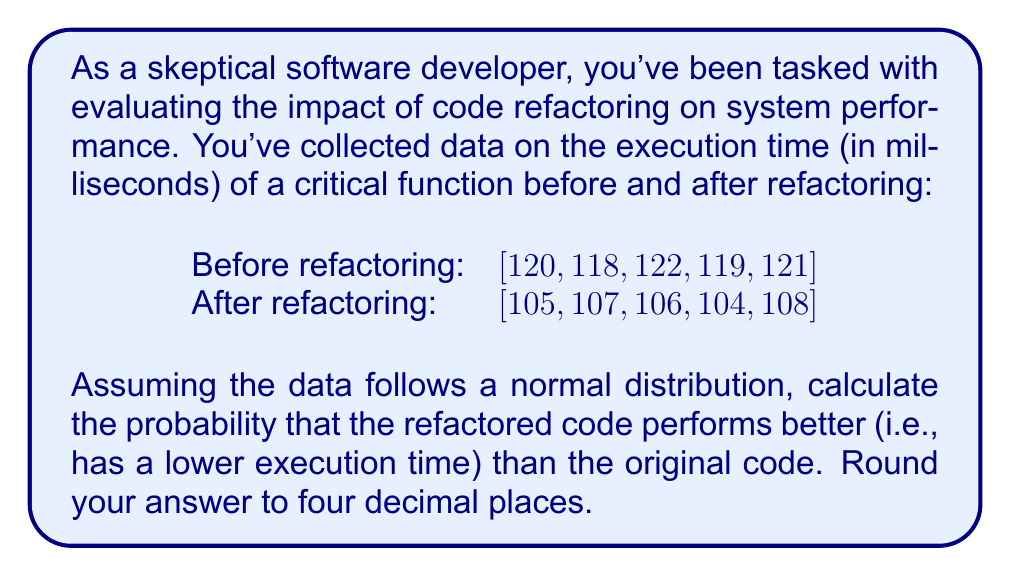Give your solution to this math problem. Let's approach this step-by-step:

1) First, we need to calculate the mean and standard deviation for both datasets:

   Before refactoring:
   Mean: $\mu_1 = \frac{120 + 118 + 122 + 119 + 121}{5} = 120$ ms
   Standard deviation: $\sigma_1 = \sqrt{\frac{\sum(x-\mu)^2}{n-1}} \approx 1.5811$ ms

   After refactoring:
   Mean: $\mu_2 = \frac{105 + 107 + 106 + 104 + 108}{5} = 106$ ms
   Standard deviation: $\sigma_2 \approx 1.5811$ ms

2) We want to find $P(X_2 < X_1)$, where $X_1$ and $X_2$ are random variables representing the execution times before and after refactoring, respectively.

3) The difference $D = X_1 - X_2$ follows a normal distribution with:
   Mean: $\mu_D = \mu_1 - \mu_2 = 120 - 106 = 14$ ms
   Variance: $\sigma_D^2 = \sigma_1^2 + \sigma_2^2 = 1.5811^2 + 1.5811^2 = 5$ ms²

4) We need to find $P(D > 0)$, which is equivalent to $P(X_2 < X_1)$

5) Standardizing D:
   $Z = \frac{D - \mu_D}{\sigma_D} = \frac{0 - 14}{\sqrt{5}} = -6.2610$

6) Using the standard normal distribution table or a calculator, we can find:
   $P(Z > -6.2610) = 1 - P(Z < -6.2610) \approx 1$

Therefore, the probability that the refactored code performs better is approximately 1 or 100% (rounded to four decimal places).
Answer: 1.0000 